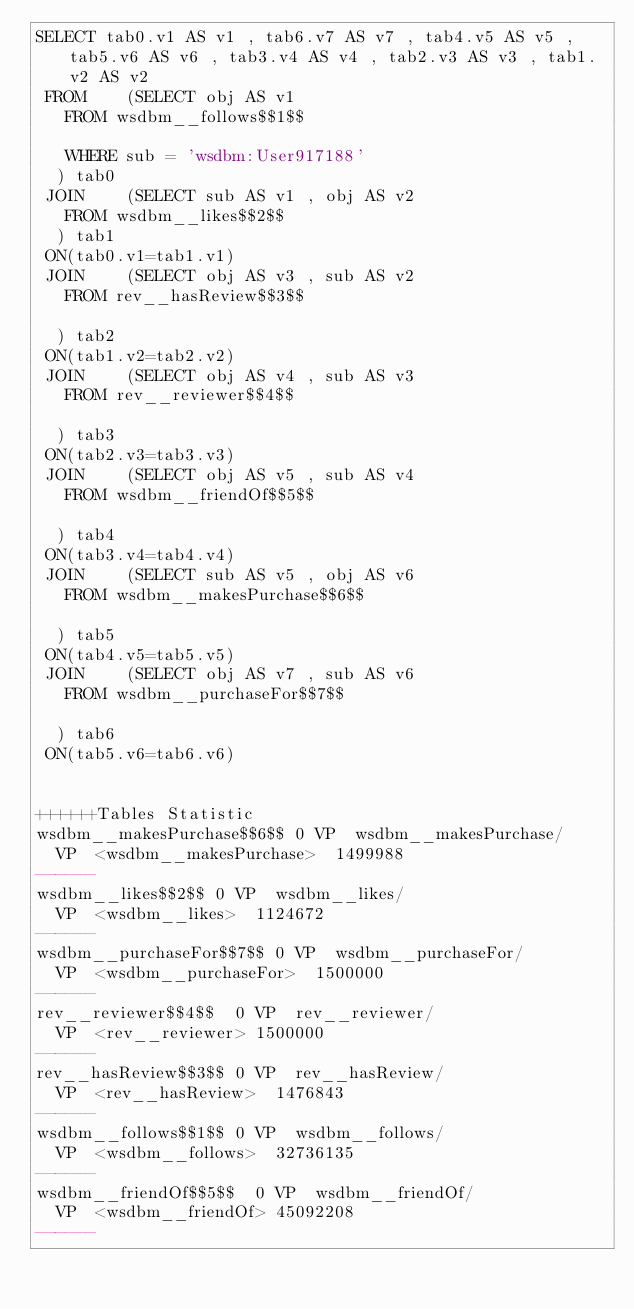Convert code to text. <code><loc_0><loc_0><loc_500><loc_500><_SQL_>SELECT tab0.v1 AS v1 , tab6.v7 AS v7 , tab4.v5 AS v5 , tab5.v6 AS v6 , tab3.v4 AS v4 , tab2.v3 AS v3 , tab1.v2 AS v2 
 FROM    (SELECT obj AS v1 
	 FROM wsdbm__follows$$1$$
	 
	 WHERE sub = 'wsdbm:User917188'
	) tab0
 JOIN    (SELECT sub AS v1 , obj AS v2 
	 FROM wsdbm__likes$$2$$
	) tab1
 ON(tab0.v1=tab1.v1)
 JOIN    (SELECT obj AS v3 , sub AS v2 
	 FROM rev__hasReview$$3$$
	
	) tab2
 ON(tab1.v2=tab2.v2)
 JOIN    (SELECT obj AS v4 , sub AS v3 
	 FROM rev__reviewer$$4$$
	
	) tab3
 ON(tab2.v3=tab3.v3)
 JOIN    (SELECT obj AS v5 , sub AS v4 
	 FROM wsdbm__friendOf$$5$$
	
	) tab4
 ON(tab3.v4=tab4.v4)
 JOIN    (SELECT sub AS v5 , obj AS v6 
	 FROM wsdbm__makesPurchase$$6$$
	
	) tab5
 ON(tab4.v5=tab5.v5)
 JOIN    (SELECT obj AS v7 , sub AS v6 
	 FROM wsdbm__purchaseFor$$7$$
	
	) tab6
 ON(tab5.v6=tab6.v6)


++++++Tables Statistic
wsdbm__makesPurchase$$6$$	0	VP	wsdbm__makesPurchase/
	VP	<wsdbm__makesPurchase>	1499988
------
wsdbm__likes$$2$$	0	VP	wsdbm__likes/
	VP	<wsdbm__likes>	1124672
------
wsdbm__purchaseFor$$7$$	0	VP	wsdbm__purchaseFor/
	VP	<wsdbm__purchaseFor>	1500000
------
rev__reviewer$$4$$	0	VP	rev__reviewer/
	VP	<rev__reviewer>	1500000
------
rev__hasReview$$3$$	0	VP	rev__hasReview/
	VP	<rev__hasReview>	1476843
------
wsdbm__follows$$1$$	0	VP	wsdbm__follows/
	VP	<wsdbm__follows>	32736135
------
wsdbm__friendOf$$5$$	0	VP	wsdbm__friendOf/
	VP	<wsdbm__friendOf>	45092208
------
</code> 